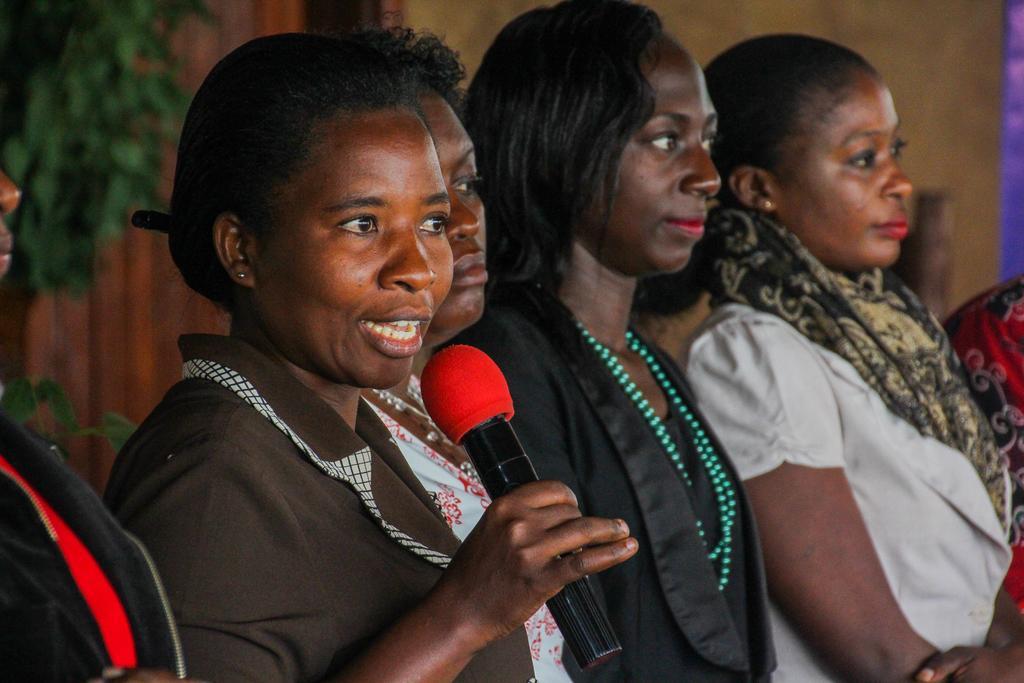How would you summarize this image in a sentence or two? In this image there are group of persons standing at the middle of the image there is a person holding microphone in her hand. 